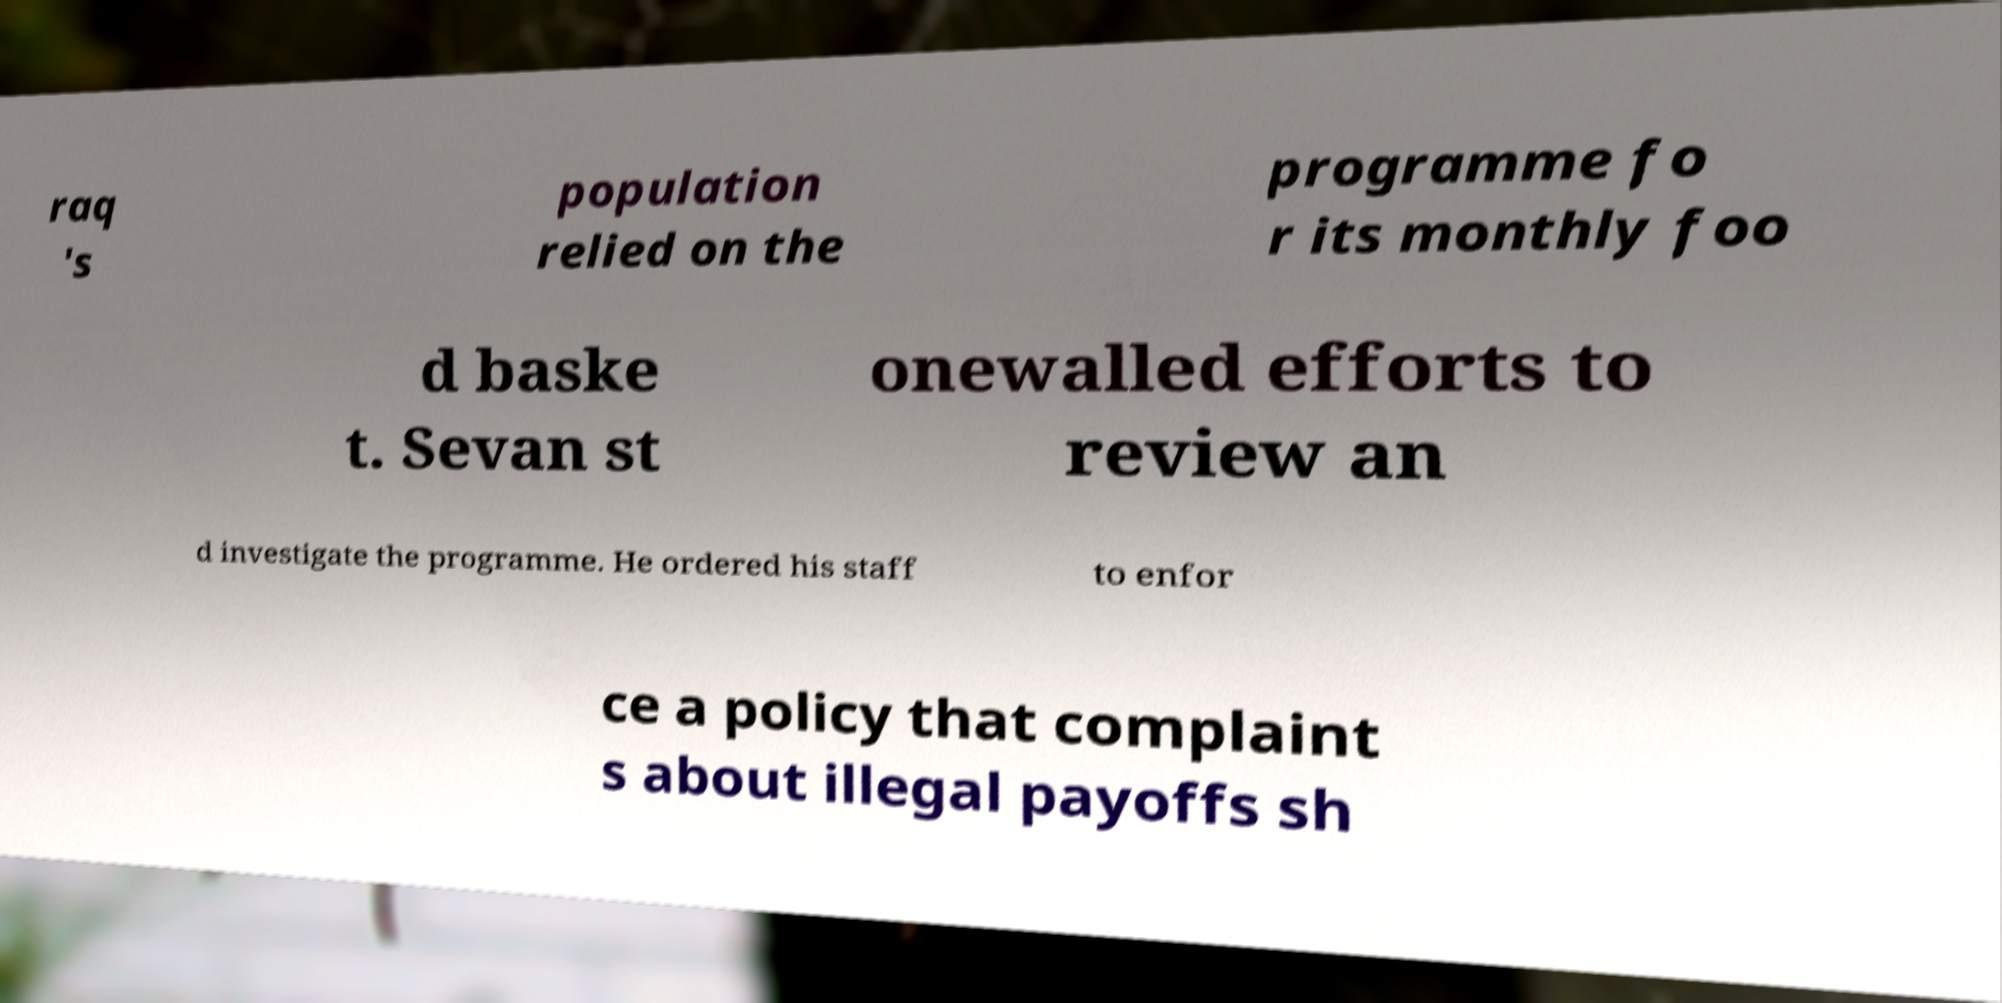Could you extract and type out the text from this image? raq 's population relied on the programme fo r its monthly foo d baske t. Sevan st onewalled efforts to review an d investigate the programme. He ordered his staff to enfor ce a policy that complaint s about illegal payoffs sh 